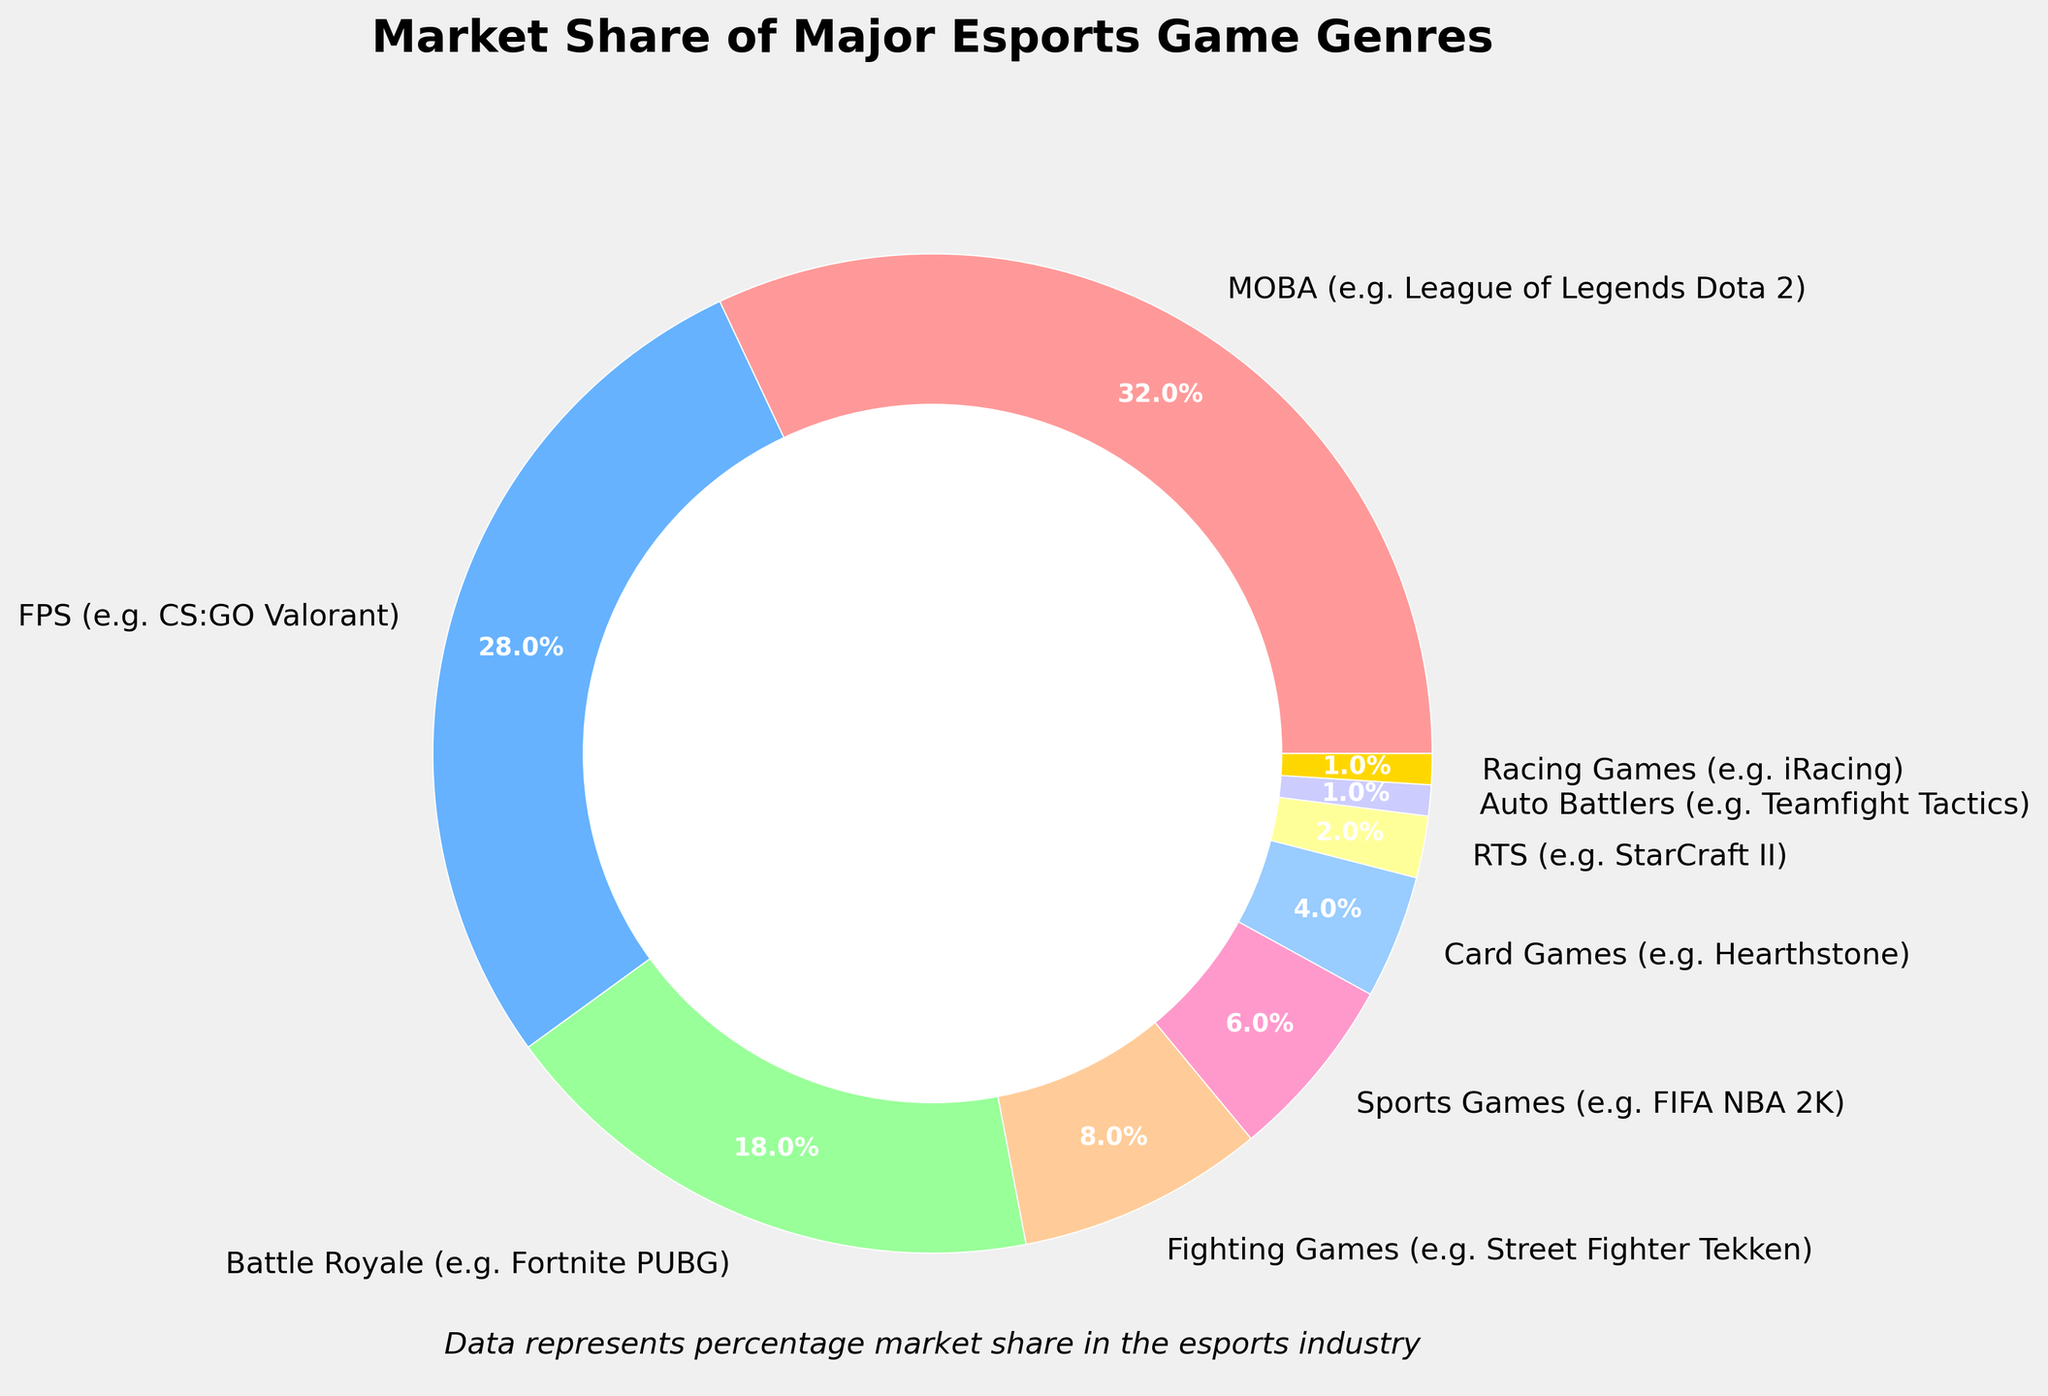What is the combined market share of MOBAs and FPS games? To find the combined market share, add the market share percentages of MOBAs (32%) and FPS games (28%). The calculation is 32% + 28% = 60%.
Answer: 60% Which genre has a higher market share: Battle Royale or Fighting Games? Compare the market share percentages of Battle Royale (18%) and Fighting Games (8%). Since 18% is greater than 8%, Battle Royales have the higher market share.
Answer: Battle Royale What is the total market share of genres that have less than 10% market share each? Identify the genres with less than 10% market share: Fighting Games (8%), Sports Games (6%), Card Games (4%), RTS (2%), Auto Battlers (1%), and Racing Games (1%). Add their percentages: 8% + 6% + 4% + 2% + 1% + 1% = 22%.
Answer: 22% Which genre has the smallest market share and what is the percentage? The genres with the smallest market share are Auto Battlers and Racing Games, which both have a market share of 1%.
Answer: Auto Battlers and Racing Games, 1% What is the difference between the market shares of MOBAs and Sports Games? Subtract the market share percentage of Sports Games (6%) from that of MOBAs (32%). The calculation is 32% - 6% = 26%.
Answer: 26% What percentage of the market is not occupied by MOBAs, FPS, and Battle Royale genres? Add the market share percentages of MOBAs (32%), FPS games (28%), and Battle Royale games (18%) first: 32% + 28% + 18% = 78%. Then subtract this from 100% to find the remaining percentage: 100% - 78% = 22%.
Answer: 22% Which genre is depicted using the green color on the chart? Identify the genre represented by the green color, which corresponds to the third listed color in the provided color sequence. The third genre listed is Battle Royale, and it has the green color.
Answer: Battle Royale 